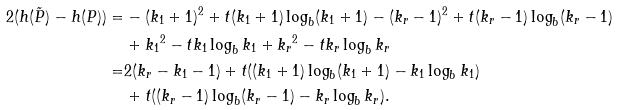Convert formula to latex. <formula><loc_0><loc_0><loc_500><loc_500>2 ( h ( \tilde { P } ) - h ( P ) ) = & - ( k _ { 1 } + 1 ) ^ { 2 } + t ( k _ { 1 } + 1 ) \log _ { b } ( k _ { 1 } + 1 ) - ( k _ { r } - 1 ) ^ { 2 } + t ( k _ { r } - 1 ) \log _ { b } ( k _ { r } - 1 ) \\ & + { k _ { 1 } } ^ { 2 } - t k _ { 1 } \log _ { b } k _ { 1 } + { k _ { r } } ^ { 2 } - t k _ { r } \log _ { b } k _ { r } \\ = & 2 ( k _ { r } - k _ { 1 } - 1 ) + t ( ( k _ { 1 } + 1 ) \log _ { b } ( k _ { 1 } + 1 ) - k _ { 1 } \log _ { b } k _ { 1 } ) \\ & + t ( ( k _ { r } - 1 ) \log _ { b } ( k _ { r } - 1 ) - k _ { r } \log _ { b } k _ { r } ) .</formula> 